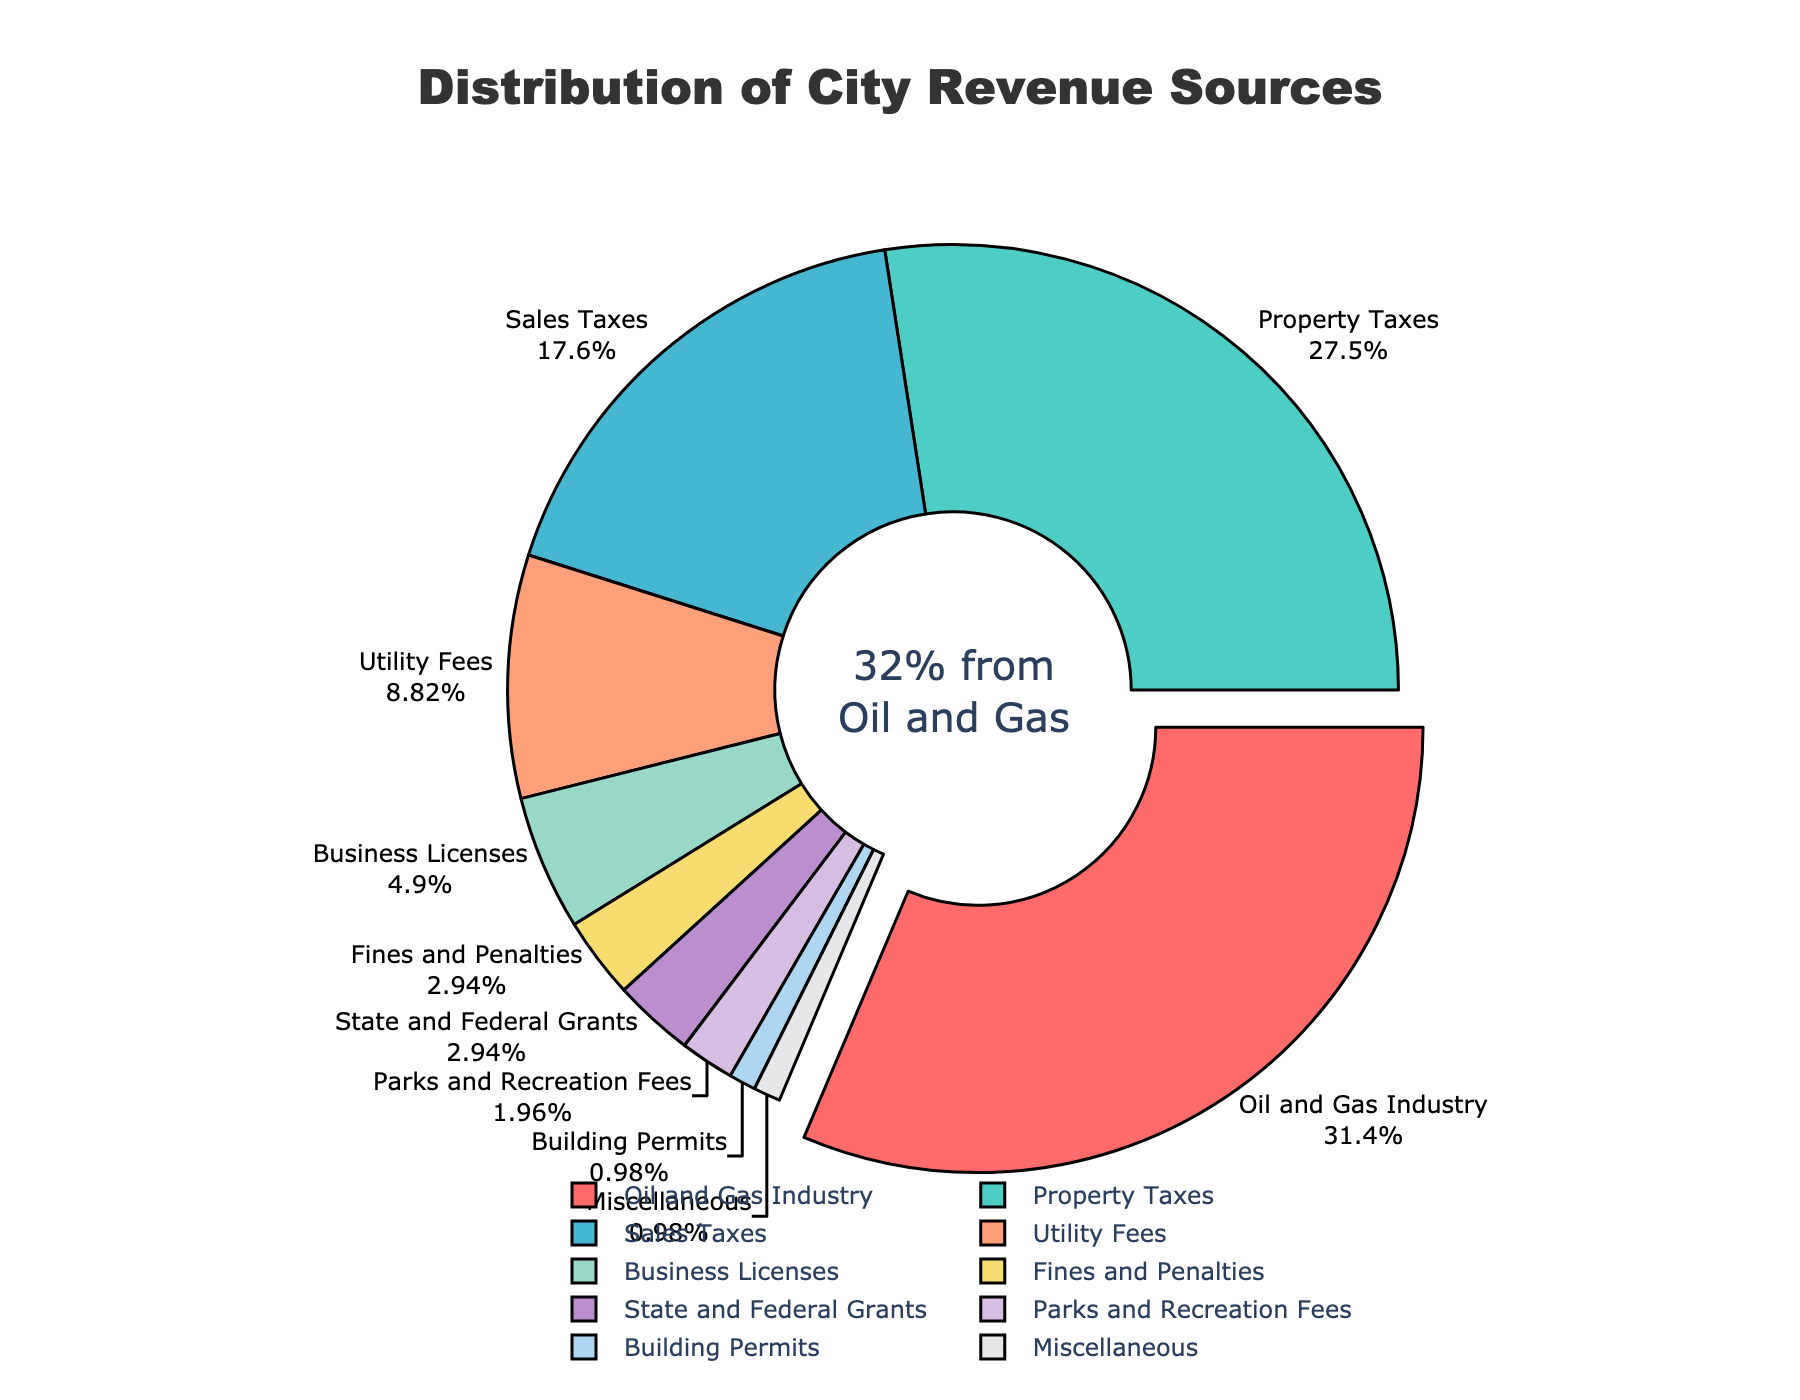What is the percentage of city revenue that comes from property taxes? The pie chart shows that the percentage of city revenue from property taxes is 28%.
Answer: 28% Which revenue source contributes more: sales taxes or property taxes? The pie chart indicates that sales taxes contribute 18% while property taxes contribute 28%. Therefore, property taxes contribute more.
Answer: Property taxes What is the total percentage of city revenue that comes from utility fees and business licenses combined? The pie chart shows utility fees at 9% and business licenses at 5%. Adding these percentages yields 14%.
Answer: 14% How does the percentage of city revenue from fines and penalties compare to that from miscellaneous sources? The pie chart shows that fines and penalties contribute 3% and miscellaneous sources contribute 1%. Therefore, fines and penalties contribute more.
Answer: Fines and penalties What are the revenue sources that collectively contribute less than 10% to the city's revenue? The pie chart identifies that utility fees (9%), business licenses (5%), fines and penalties (3%), state and federal grants (3%), parks and recreation fees (2%), building permits (1%), and miscellaneous (1%) collectively contribute less than 10%.
Answer: State and federal grants, parks and recreation fees, building permits, miscellaneous What is the difference in the percentage of city revenue from oil and gas industry and property taxes? The pie chart shows that the oil and gas industry provides 32% while property taxes provide 28%. Thus, the difference is 4%.
Answer: 4% What percentage of city revenue comes from sources other than oil and gas industry? By subtracting the oil and gas industry’s contribution (32%) from 100%, we determine that 68% of revenue comes from other sources.
Answer: 68% Which revenue source is depicted with the largest pull-out effect in the pie chart? The oil and gas industry segment is visually pulled out of the pie chart, making it prominent.
Answer: Oil and gas industry 